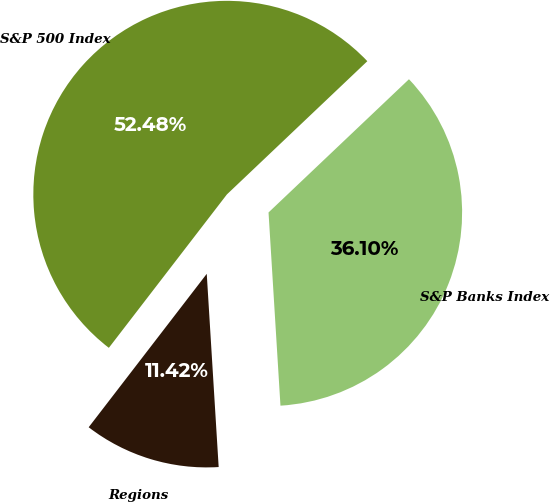<chart> <loc_0><loc_0><loc_500><loc_500><pie_chart><fcel>Regions<fcel>S&P 500 Index<fcel>S&P Banks Index<nl><fcel>11.42%<fcel>52.48%<fcel>36.1%<nl></chart> 